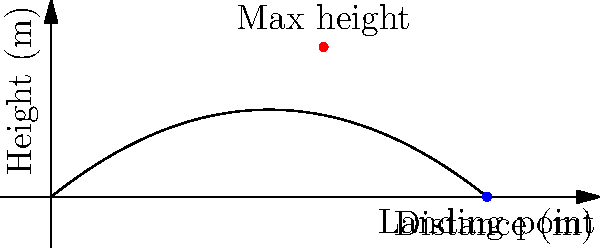As a sports reporter covering a local football match in Parma, you observe a player kicking a ball. The trajectory of the ball can be modeled by the equation $h(x) = -0.05x^2 + 0.8x$, where $h$ is the height in meters and $x$ is the horizontal distance in meters. What is the total horizontal distance the ball travels before hitting the ground? To find the total horizontal distance, we need to determine where the ball hits the ground, which occurs when the height $h(x)$ equals zero.

1) Set up the equation:
   $0 = -0.05x^2 + 0.8x$

2) Rearrange the equation:
   $0.05x^2 - 0.8x = 0$

3) Factor out the common factor:
   $x(0.05x - 0.8) = 0$

4) Use the zero product property. The solutions are:
   $x = 0$ or $0.05x - 0.8 = 0$

5) Solve the second equation:
   $0.05x = 0.8$
   $x = 0.8 / 0.05 = 16$

6) The solution $x = 0$ represents the starting point, so we can discard it.

Therefore, the ball hits the ground at $x = 16$ meters.
Answer: 16 meters 